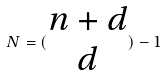Convert formula to latex. <formula><loc_0><loc_0><loc_500><loc_500>N = ( \begin{matrix} n + d \\ d \end{matrix} ) - 1</formula> 